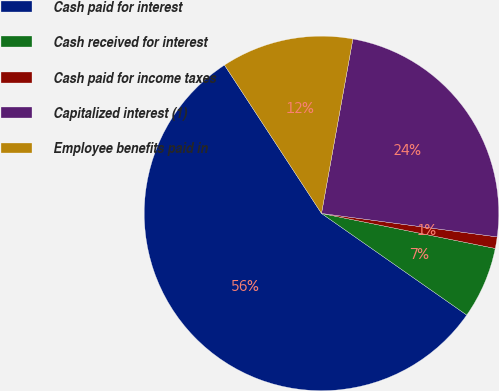Convert chart. <chart><loc_0><loc_0><loc_500><loc_500><pie_chart><fcel>Cash paid for interest<fcel>Cash received for interest<fcel>Cash paid for income taxes<fcel>Capitalized interest (1)<fcel>Employee benefits paid in<nl><fcel>56.06%<fcel>6.55%<fcel>1.05%<fcel>24.28%<fcel>12.05%<nl></chart> 